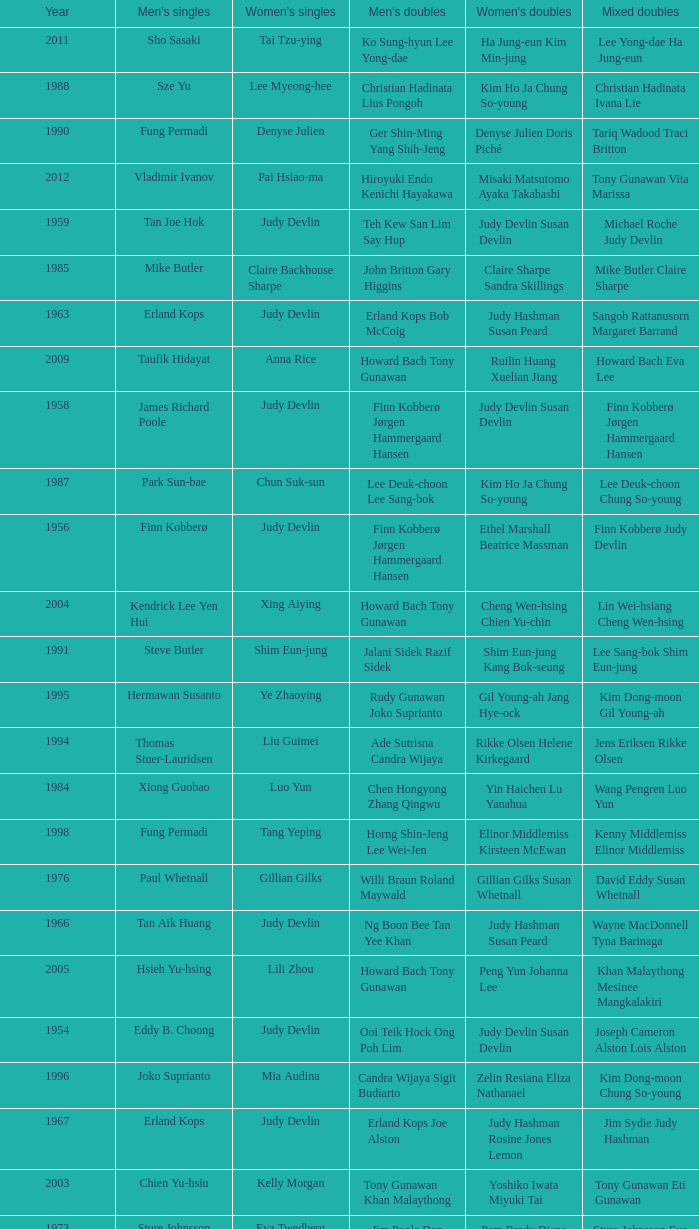Who was the women's singles champion in 1984? Luo Yun. 